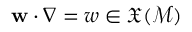<formula> <loc_0><loc_0><loc_500><loc_500>w \cdot \nabla = w \in \mathfrak { X } ( \mathcal { M } )</formula> 